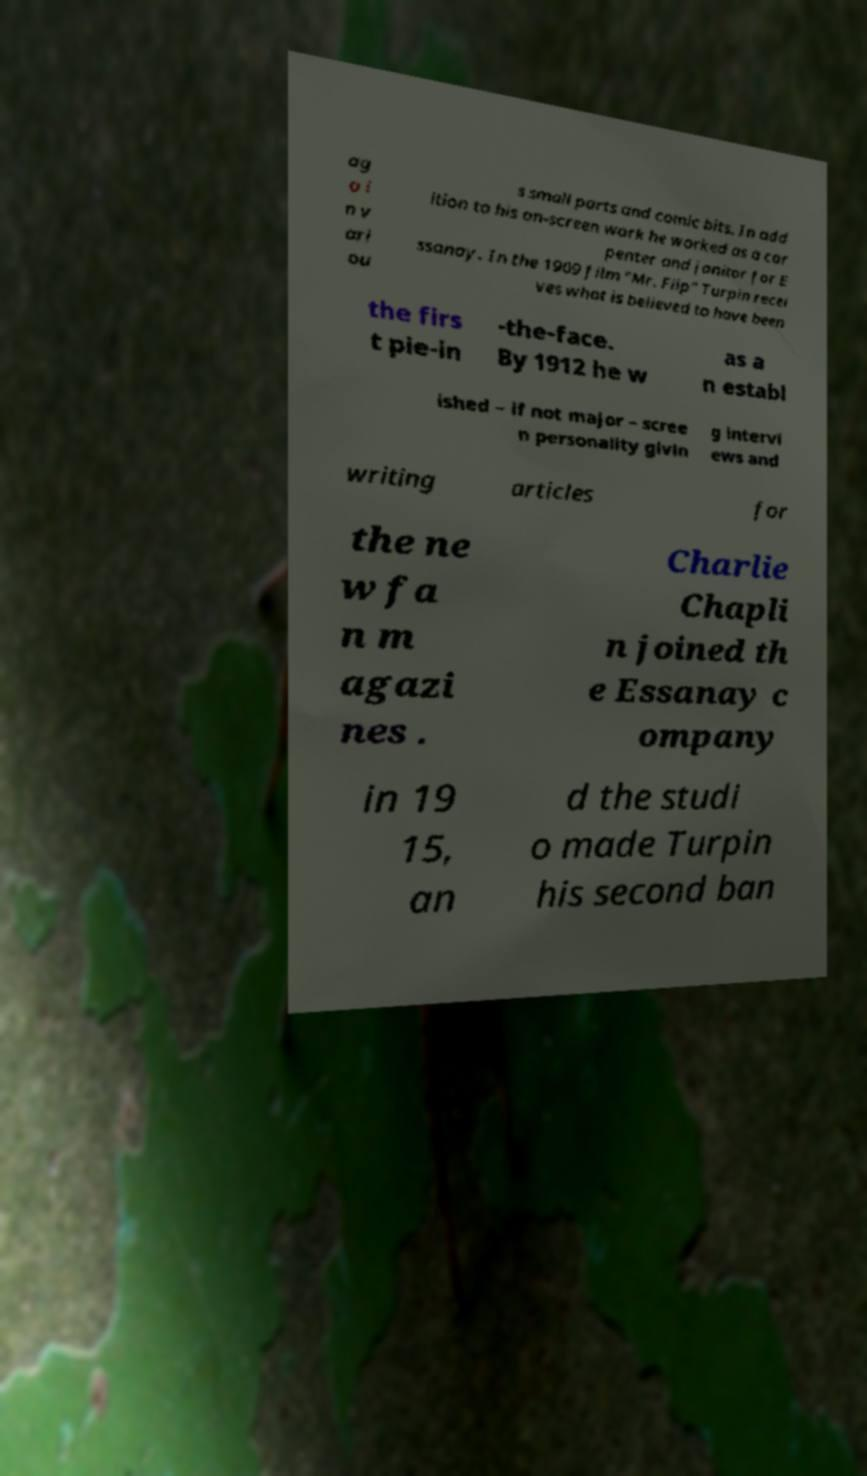Can you read and provide the text displayed in the image?This photo seems to have some interesting text. Can you extract and type it out for me? ag o i n v ari ou s small parts and comic bits. In add ition to his on-screen work he worked as a car penter and janitor for E ssanay. In the 1909 film "Mr. Flip" Turpin recei ves what is believed to have been the firs t pie-in -the-face. By 1912 he w as a n establ ished – if not major – scree n personality givin g intervi ews and writing articles for the ne w fa n m agazi nes . Charlie Chapli n joined th e Essanay c ompany in 19 15, an d the studi o made Turpin his second ban 